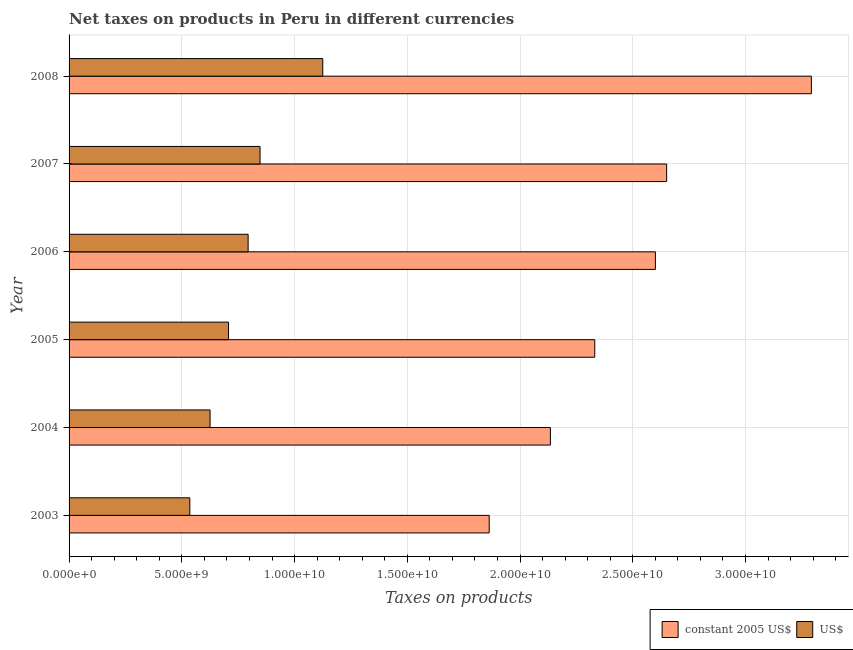Are the number of bars per tick equal to the number of legend labels?
Make the answer very short. Yes. Are the number of bars on each tick of the Y-axis equal?
Offer a very short reply. Yes. What is the label of the 5th group of bars from the top?
Make the answer very short. 2004. In how many cases, is the number of bars for a given year not equal to the number of legend labels?
Make the answer very short. 0. What is the net taxes in constant 2005 us$ in 2008?
Offer a very short reply. 3.29e+1. Across all years, what is the maximum net taxes in constant 2005 us$?
Offer a terse response. 3.29e+1. Across all years, what is the minimum net taxes in us$?
Your answer should be very brief. 5.36e+09. In which year was the net taxes in constant 2005 us$ maximum?
Your answer should be compact. 2008. What is the total net taxes in constant 2005 us$ in the graph?
Ensure brevity in your answer.  1.49e+11. What is the difference between the net taxes in constant 2005 us$ in 2005 and that in 2008?
Give a very brief answer. -9.61e+09. What is the difference between the net taxes in constant 2005 us$ in 2008 and the net taxes in us$ in 2007?
Give a very brief answer. 2.45e+1. What is the average net taxes in constant 2005 us$ per year?
Make the answer very short. 2.48e+1. In the year 2006, what is the difference between the net taxes in constant 2005 us$ and net taxes in us$?
Give a very brief answer. 1.81e+1. In how many years, is the net taxes in us$ greater than 32000000000 units?
Your response must be concise. 0. What is the ratio of the net taxes in us$ in 2003 to that in 2007?
Make the answer very short. 0.63. Is the net taxes in constant 2005 us$ in 2003 less than that in 2004?
Keep it short and to the point. Yes. Is the difference between the net taxes in constant 2005 us$ in 2003 and 2006 greater than the difference between the net taxes in us$ in 2003 and 2006?
Your answer should be very brief. No. What is the difference between the highest and the second highest net taxes in constant 2005 us$?
Offer a terse response. 6.42e+09. What is the difference between the highest and the lowest net taxes in constant 2005 us$?
Provide a succinct answer. 1.43e+1. Is the sum of the net taxes in us$ in 2003 and 2004 greater than the maximum net taxes in constant 2005 us$ across all years?
Give a very brief answer. No. What does the 1st bar from the top in 2005 represents?
Provide a succinct answer. US$. What does the 2nd bar from the bottom in 2007 represents?
Your answer should be compact. US$. How many bars are there?
Offer a very short reply. 12. Does the graph contain grids?
Provide a succinct answer. Yes. Where does the legend appear in the graph?
Your answer should be compact. Bottom right. How are the legend labels stacked?
Keep it short and to the point. Horizontal. What is the title of the graph?
Provide a succinct answer. Net taxes on products in Peru in different currencies. Does "Nitrous oxide emissions" appear as one of the legend labels in the graph?
Make the answer very short. No. What is the label or title of the X-axis?
Give a very brief answer. Taxes on products. What is the label or title of the Y-axis?
Your response must be concise. Year. What is the Taxes on products in constant 2005 US$ in 2003?
Offer a terse response. 1.86e+1. What is the Taxes on products in US$ in 2003?
Make the answer very short. 5.36e+09. What is the Taxes on products in constant 2005 US$ in 2004?
Your answer should be compact. 2.13e+1. What is the Taxes on products in US$ in 2004?
Provide a short and direct response. 6.25e+09. What is the Taxes on products of constant 2005 US$ in 2005?
Provide a short and direct response. 2.33e+1. What is the Taxes on products in US$ in 2005?
Provide a succinct answer. 7.07e+09. What is the Taxes on products in constant 2005 US$ in 2006?
Your answer should be very brief. 2.60e+1. What is the Taxes on products of US$ in 2006?
Give a very brief answer. 7.94e+09. What is the Taxes on products of constant 2005 US$ in 2007?
Your response must be concise. 2.65e+1. What is the Taxes on products in US$ in 2007?
Offer a very short reply. 8.47e+09. What is the Taxes on products of constant 2005 US$ in 2008?
Make the answer very short. 3.29e+1. What is the Taxes on products of US$ in 2008?
Give a very brief answer. 1.13e+1. Across all years, what is the maximum Taxes on products of constant 2005 US$?
Your answer should be very brief. 3.29e+1. Across all years, what is the maximum Taxes on products of US$?
Provide a short and direct response. 1.13e+1. Across all years, what is the minimum Taxes on products of constant 2005 US$?
Your answer should be compact. 1.86e+1. Across all years, what is the minimum Taxes on products of US$?
Offer a very short reply. 5.36e+09. What is the total Taxes on products of constant 2005 US$ in the graph?
Offer a very short reply. 1.49e+11. What is the total Taxes on products in US$ in the graph?
Offer a very short reply. 4.63e+1. What is the difference between the Taxes on products of constant 2005 US$ in 2003 and that in 2004?
Offer a very short reply. -2.71e+09. What is the difference between the Taxes on products of US$ in 2003 and that in 2004?
Keep it short and to the point. -8.98e+08. What is the difference between the Taxes on products in constant 2005 US$ in 2003 and that in 2005?
Your response must be concise. -4.68e+09. What is the difference between the Taxes on products of US$ in 2003 and that in 2005?
Provide a succinct answer. -1.72e+09. What is the difference between the Taxes on products of constant 2005 US$ in 2003 and that in 2006?
Make the answer very short. -7.37e+09. What is the difference between the Taxes on products in US$ in 2003 and that in 2006?
Offer a terse response. -2.59e+09. What is the difference between the Taxes on products in constant 2005 US$ in 2003 and that in 2007?
Your response must be concise. -7.87e+09. What is the difference between the Taxes on products in US$ in 2003 and that in 2007?
Provide a succinct answer. -3.11e+09. What is the difference between the Taxes on products in constant 2005 US$ in 2003 and that in 2008?
Give a very brief answer. -1.43e+1. What is the difference between the Taxes on products in US$ in 2003 and that in 2008?
Keep it short and to the point. -5.90e+09. What is the difference between the Taxes on products of constant 2005 US$ in 2004 and that in 2005?
Provide a short and direct response. -1.97e+09. What is the difference between the Taxes on products of US$ in 2004 and that in 2005?
Your answer should be compact. -8.19e+08. What is the difference between the Taxes on products of constant 2005 US$ in 2004 and that in 2006?
Your response must be concise. -4.66e+09. What is the difference between the Taxes on products of US$ in 2004 and that in 2006?
Keep it short and to the point. -1.69e+09. What is the difference between the Taxes on products of constant 2005 US$ in 2004 and that in 2007?
Keep it short and to the point. -5.16e+09. What is the difference between the Taxes on products of US$ in 2004 and that in 2007?
Your response must be concise. -2.22e+09. What is the difference between the Taxes on products of constant 2005 US$ in 2004 and that in 2008?
Keep it short and to the point. -1.16e+1. What is the difference between the Taxes on products of US$ in 2004 and that in 2008?
Keep it short and to the point. -5.00e+09. What is the difference between the Taxes on products of constant 2005 US$ in 2005 and that in 2006?
Your response must be concise. -2.69e+09. What is the difference between the Taxes on products of US$ in 2005 and that in 2006?
Keep it short and to the point. -8.69e+08. What is the difference between the Taxes on products of constant 2005 US$ in 2005 and that in 2007?
Your answer should be very brief. -3.19e+09. What is the difference between the Taxes on products of US$ in 2005 and that in 2007?
Your response must be concise. -1.40e+09. What is the difference between the Taxes on products of constant 2005 US$ in 2005 and that in 2008?
Make the answer very short. -9.61e+09. What is the difference between the Taxes on products in US$ in 2005 and that in 2008?
Offer a terse response. -4.18e+09. What is the difference between the Taxes on products of constant 2005 US$ in 2006 and that in 2007?
Your answer should be compact. -4.99e+08. What is the difference between the Taxes on products of US$ in 2006 and that in 2007?
Your response must be concise. -5.29e+08. What is the difference between the Taxes on products in constant 2005 US$ in 2006 and that in 2008?
Provide a short and direct response. -6.92e+09. What is the difference between the Taxes on products of US$ in 2006 and that in 2008?
Provide a short and direct response. -3.31e+09. What is the difference between the Taxes on products of constant 2005 US$ in 2007 and that in 2008?
Your answer should be compact. -6.42e+09. What is the difference between the Taxes on products of US$ in 2007 and that in 2008?
Your answer should be very brief. -2.78e+09. What is the difference between the Taxes on products in constant 2005 US$ in 2003 and the Taxes on products in US$ in 2004?
Keep it short and to the point. 1.24e+1. What is the difference between the Taxes on products in constant 2005 US$ in 2003 and the Taxes on products in US$ in 2005?
Offer a terse response. 1.16e+1. What is the difference between the Taxes on products of constant 2005 US$ in 2003 and the Taxes on products of US$ in 2006?
Keep it short and to the point. 1.07e+1. What is the difference between the Taxes on products in constant 2005 US$ in 2003 and the Taxes on products in US$ in 2007?
Your response must be concise. 1.02e+1. What is the difference between the Taxes on products of constant 2005 US$ in 2003 and the Taxes on products of US$ in 2008?
Make the answer very short. 7.38e+09. What is the difference between the Taxes on products of constant 2005 US$ in 2004 and the Taxes on products of US$ in 2005?
Provide a short and direct response. 1.43e+1. What is the difference between the Taxes on products in constant 2005 US$ in 2004 and the Taxes on products in US$ in 2006?
Your answer should be compact. 1.34e+1. What is the difference between the Taxes on products of constant 2005 US$ in 2004 and the Taxes on products of US$ in 2007?
Your response must be concise. 1.29e+1. What is the difference between the Taxes on products in constant 2005 US$ in 2004 and the Taxes on products in US$ in 2008?
Make the answer very short. 1.01e+1. What is the difference between the Taxes on products in constant 2005 US$ in 2005 and the Taxes on products in US$ in 2006?
Your answer should be compact. 1.54e+1. What is the difference between the Taxes on products of constant 2005 US$ in 2005 and the Taxes on products of US$ in 2007?
Provide a succinct answer. 1.48e+1. What is the difference between the Taxes on products of constant 2005 US$ in 2005 and the Taxes on products of US$ in 2008?
Give a very brief answer. 1.21e+1. What is the difference between the Taxes on products of constant 2005 US$ in 2006 and the Taxes on products of US$ in 2007?
Your answer should be compact. 1.75e+1. What is the difference between the Taxes on products of constant 2005 US$ in 2006 and the Taxes on products of US$ in 2008?
Offer a terse response. 1.48e+1. What is the difference between the Taxes on products of constant 2005 US$ in 2007 and the Taxes on products of US$ in 2008?
Make the answer very short. 1.53e+1. What is the average Taxes on products of constant 2005 US$ per year?
Give a very brief answer. 2.48e+1. What is the average Taxes on products of US$ per year?
Your answer should be very brief. 7.72e+09. In the year 2003, what is the difference between the Taxes on products in constant 2005 US$ and Taxes on products in US$?
Offer a very short reply. 1.33e+1. In the year 2004, what is the difference between the Taxes on products of constant 2005 US$ and Taxes on products of US$?
Your response must be concise. 1.51e+1. In the year 2005, what is the difference between the Taxes on products in constant 2005 US$ and Taxes on products in US$?
Your response must be concise. 1.62e+1. In the year 2006, what is the difference between the Taxes on products in constant 2005 US$ and Taxes on products in US$?
Make the answer very short. 1.81e+1. In the year 2007, what is the difference between the Taxes on products in constant 2005 US$ and Taxes on products in US$?
Your answer should be very brief. 1.80e+1. In the year 2008, what is the difference between the Taxes on products of constant 2005 US$ and Taxes on products of US$?
Make the answer very short. 2.17e+1. What is the ratio of the Taxes on products in constant 2005 US$ in 2003 to that in 2004?
Keep it short and to the point. 0.87. What is the ratio of the Taxes on products in US$ in 2003 to that in 2004?
Provide a short and direct response. 0.86. What is the ratio of the Taxes on products in constant 2005 US$ in 2003 to that in 2005?
Ensure brevity in your answer.  0.8. What is the ratio of the Taxes on products of US$ in 2003 to that in 2005?
Your response must be concise. 0.76. What is the ratio of the Taxes on products in constant 2005 US$ in 2003 to that in 2006?
Your response must be concise. 0.72. What is the ratio of the Taxes on products of US$ in 2003 to that in 2006?
Keep it short and to the point. 0.67. What is the ratio of the Taxes on products of constant 2005 US$ in 2003 to that in 2007?
Provide a short and direct response. 0.7. What is the ratio of the Taxes on products of US$ in 2003 to that in 2007?
Make the answer very short. 0.63. What is the ratio of the Taxes on products of constant 2005 US$ in 2003 to that in 2008?
Ensure brevity in your answer.  0.57. What is the ratio of the Taxes on products of US$ in 2003 to that in 2008?
Keep it short and to the point. 0.48. What is the ratio of the Taxes on products of constant 2005 US$ in 2004 to that in 2005?
Your answer should be very brief. 0.92. What is the ratio of the Taxes on products in US$ in 2004 to that in 2005?
Give a very brief answer. 0.88. What is the ratio of the Taxes on products of constant 2005 US$ in 2004 to that in 2006?
Make the answer very short. 0.82. What is the ratio of the Taxes on products in US$ in 2004 to that in 2006?
Provide a short and direct response. 0.79. What is the ratio of the Taxes on products of constant 2005 US$ in 2004 to that in 2007?
Provide a short and direct response. 0.81. What is the ratio of the Taxes on products of US$ in 2004 to that in 2007?
Offer a very short reply. 0.74. What is the ratio of the Taxes on products of constant 2005 US$ in 2004 to that in 2008?
Offer a very short reply. 0.65. What is the ratio of the Taxes on products of US$ in 2004 to that in 2008?
Provide a short and direct response. 0.56. What is the ratio of the Taxes on products in constant 2005 US$ in 2005 to that in 2006?
Ensure brevity in your answer.  0.9. What is the ratio of the Taxes on products in US$ in 2005 to that in 2006?
Your answer should be compact. 0.89. What is the ratio of the Taxes on products of constant 2005 US$ in 2005 to that in 2007?
Your response must be concise. 0.88. What is the ratio of the Taxes on products of US$ in 2005 to that in 2007?
Keep it short and to the point. 0.83. What is the ratio of the Taxes on products in constant 2005 US$ in 2005 to that in 2008?
Your response must be concise. 0.71. What is the ratio of the Taxes on products of US$ in 2005 to that in 2008?
Give a very brief answer. 0.63. What is the ratio of the Taxes on products in constant 2005 US$ in 2006 to that in 2007?
Your answer should be very brief. 0.98. What is the ratio of the Taxes on products of US$ in 2006 to that in 2007?
Offer a very short reply. 0.94. What is the ratio of the Taxes on products in constant 2005 US$ in 2006 to that in 2008?
Your answer should be very brief. 0.79. What is the ratio of the Taxes on products in US$ in 2006 to that in 2008?
Give a very brief answer. 0.71. What is the ratio of the Taxes on products of constant 2005 US$ in 2007 to that in 2008?
Your answer should be compact. 0.81. What is the ratio of the Taxes on products of US$ in 2007 to that in 2008?
Offer a terse response. 0.75. What is the difference between the highest and the second highest Taxes on products of constant 2005 US$?
Provide a short and direct response. 6.42e+09. What is the difference between the highest and the second highest Taxes on products of US$?
Your response must be concise. 2.78e+09. What is the difference between the highest and the lowest Taxes on products of constant 2005 US$?
Keep it short and to the point. 1.43e+1. What is the difference between the highest and the lowest Taxes on products in US$?
Offer a very short reply. 5.90e+09. 